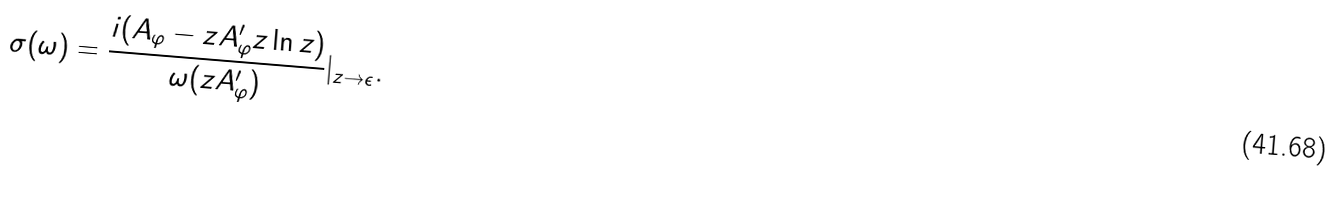Convert formula to latex. <formula><loc_0><loc_0><loc_500><loc_500>\sigma ( \omega ) = \frac { i ( A _ { \varphi } - z A ^ { \prime } _ { \varphi } z \ln { z } ) } { \omega ( z A ^ { \prime } _ { \varphi } ) } | _ { z \rightarrow \epsilon } .</formula> 